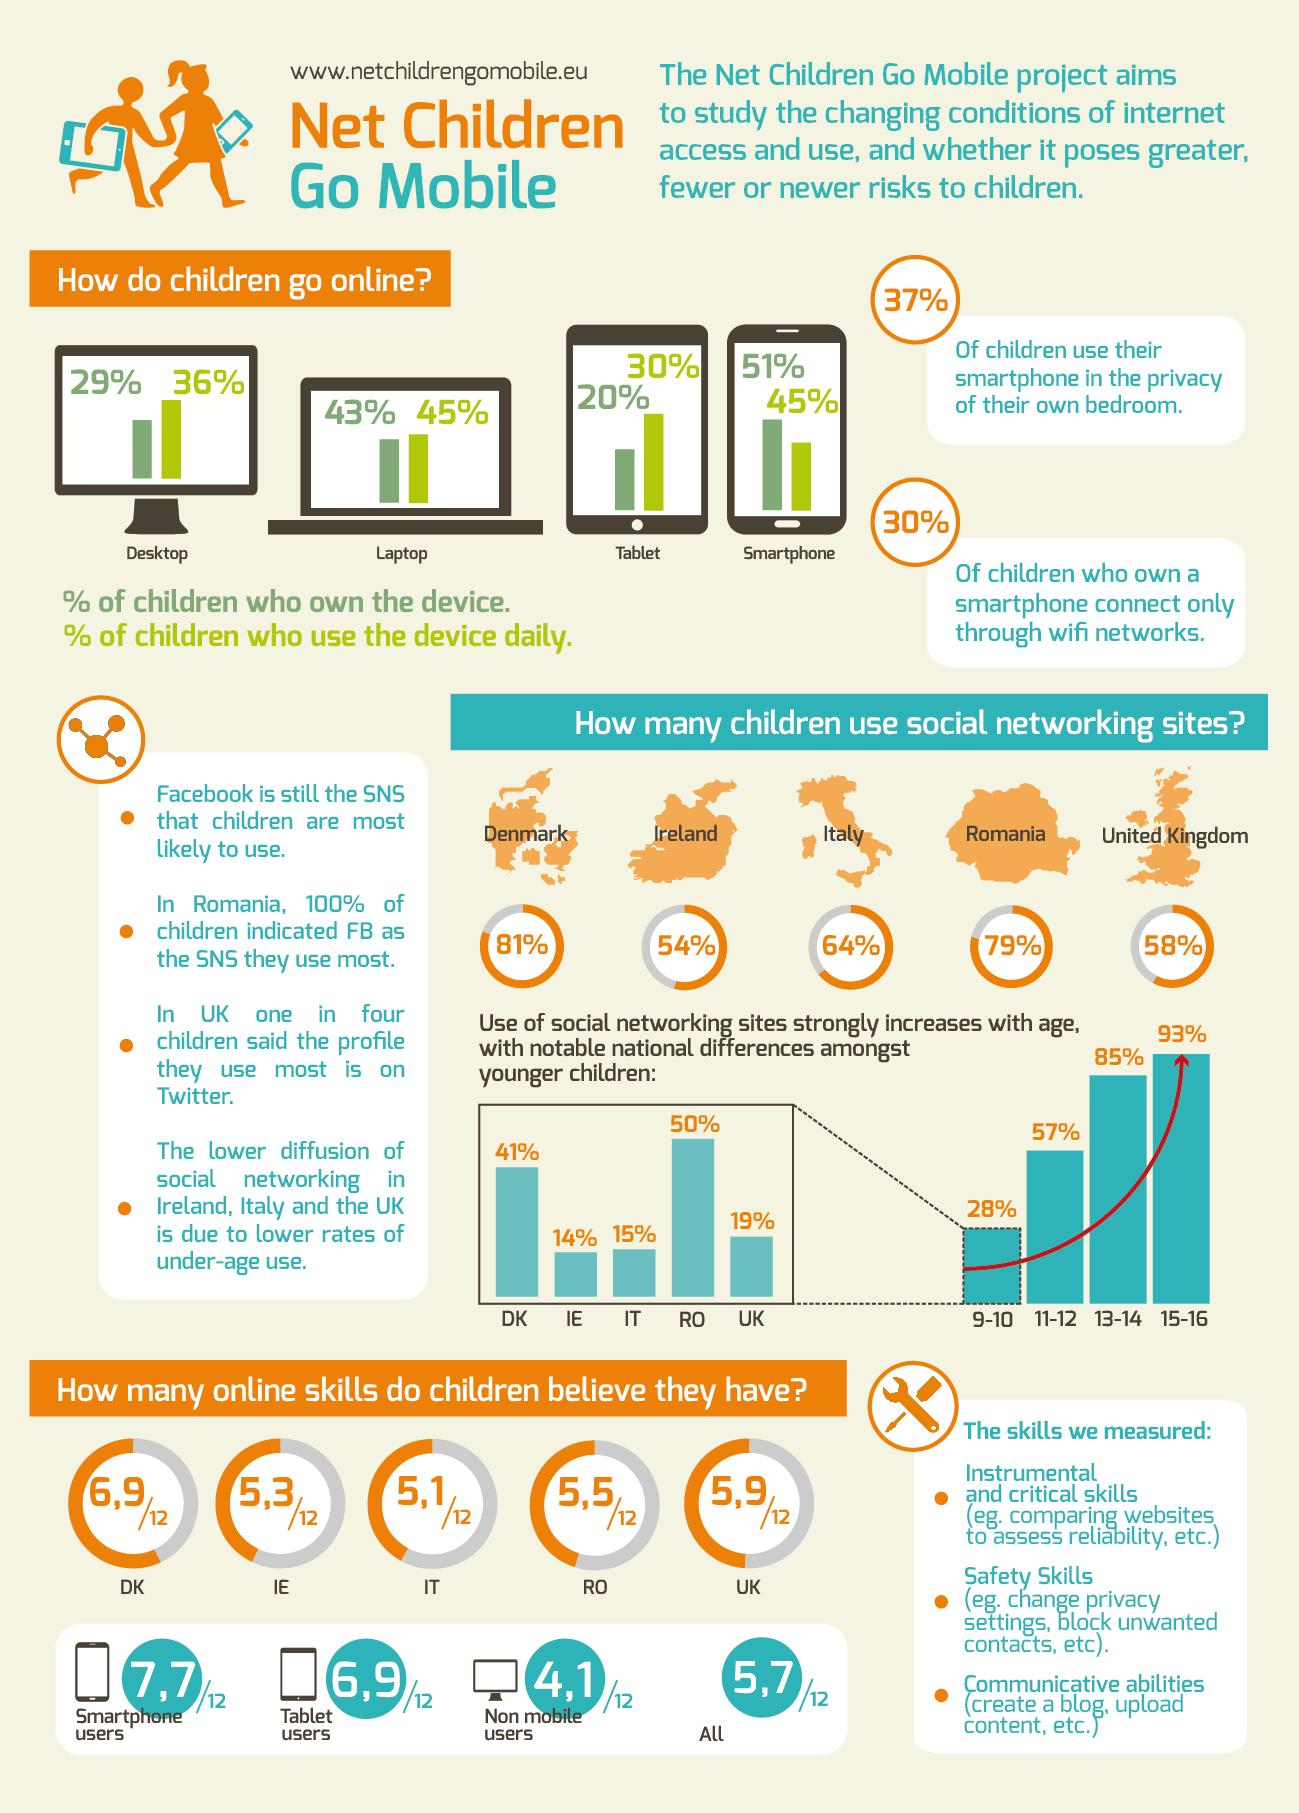Specify some key components in this picture. The increased usage of social networking sites among children is directly proportional to their age. Romania comes in second place in terms of the percentage of children who use social networking sites the most. According to recent studies, Denmark has the highest percentage of children who use social networking sites the most. The second age group in children who use social networking sites are those between the ages of 13 and 14. 